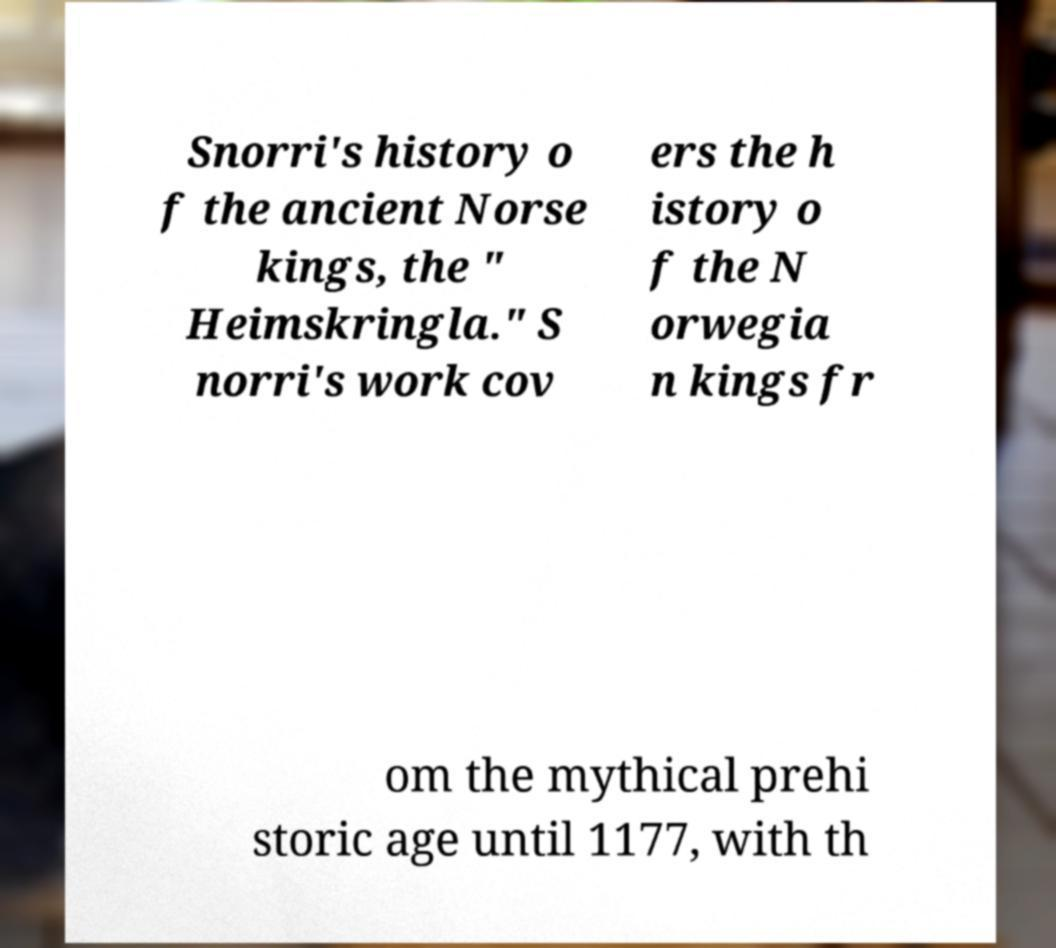There's text embedded in this image that I need extracted. Can you transcribe it verbatim? Snorri's history o f the ancient Norse kings, the " Heimskringla." S norri's work cov ers the h istory o f the N orwegia n kings fr om the mythical prehi storic age until 1177, with th 